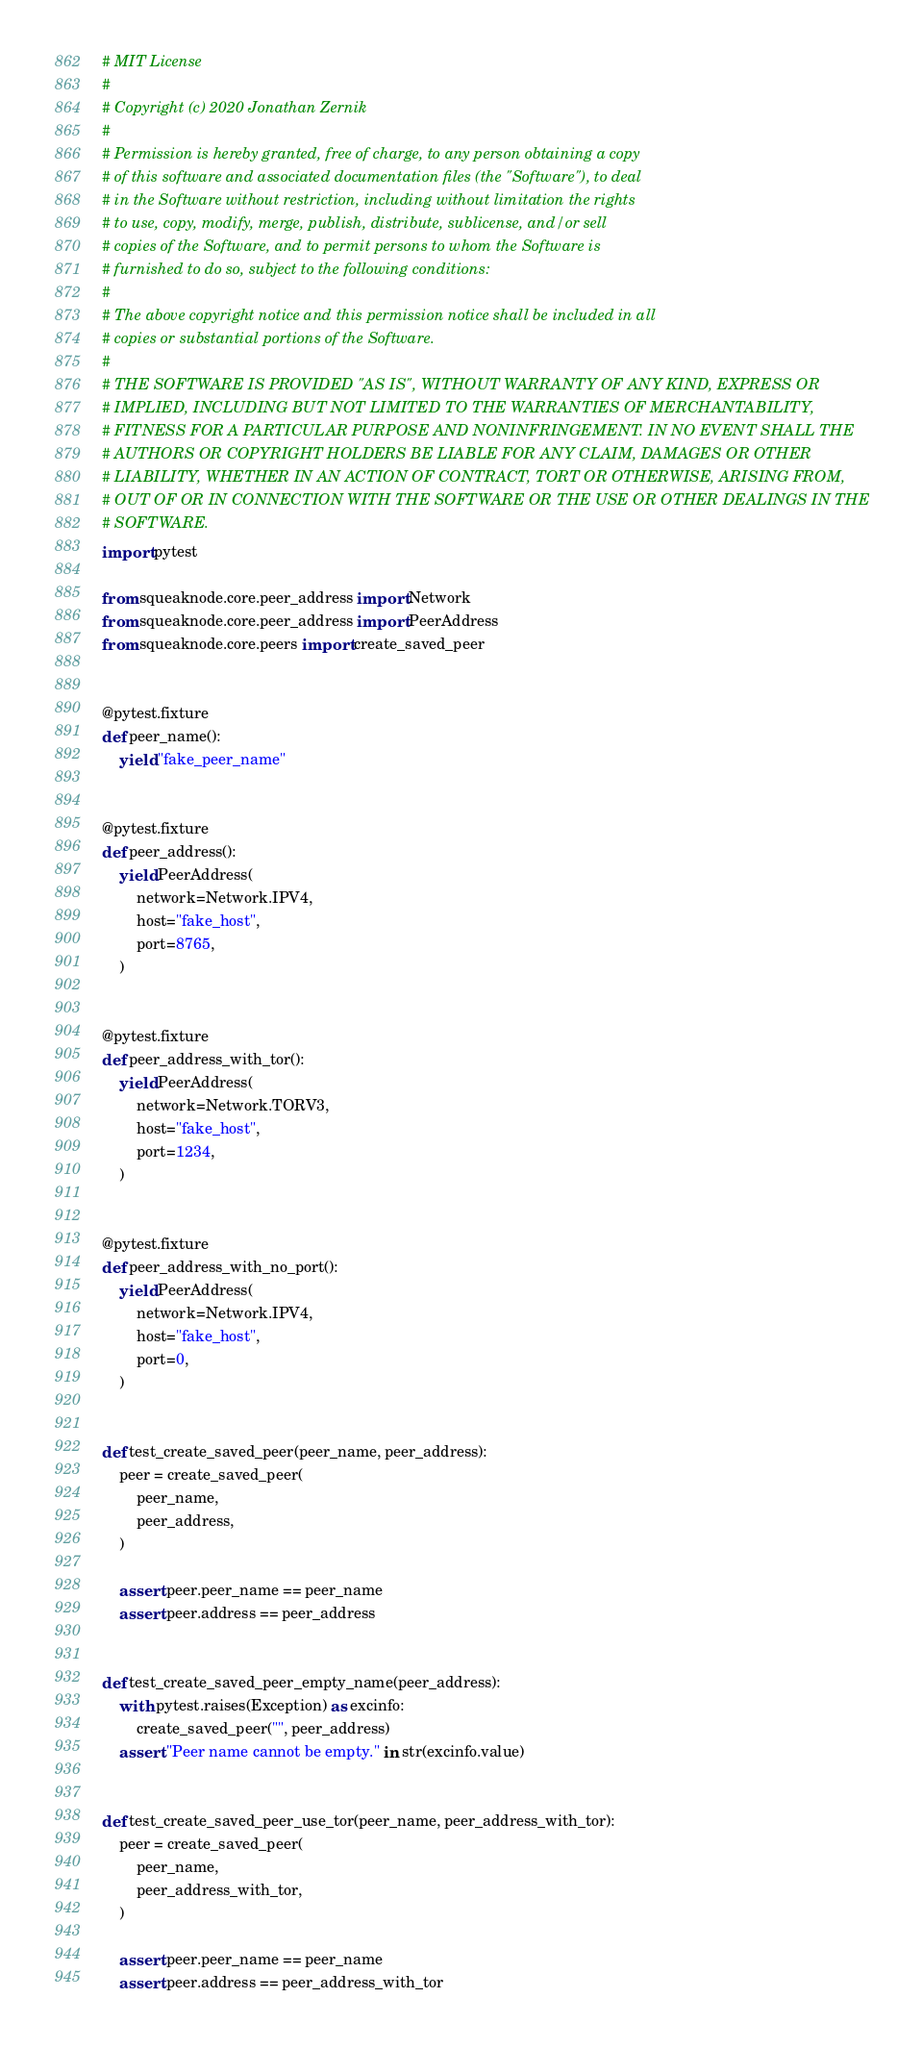<code> <loc_0><loc_0><loc_500><loc_500><_Python_># MIT License
#
# Copyright (c) 2020 Jonathan Zernik
#
# Permission is hereby granted, free of charge, to any person obtaining a copy
# of this software and associated documentation files (the "Software"), to deal
# in the Software without restriction, including without limitation the rights
# to use, copy, modify, merge, publish, distribute, sublicense, and/or sell
# copies of the Software, and to permit persons to whom the Software is
# furnished to do so, subject to the following conditions:
#
# The above copyright notice and this permission notice shall be included in all
# copies or substantial portions of the Software.
#
# THE SOFTWARE IS PROVIDED "AS IS", WITHOUT WARRANTY OF ANY KIND, EXPRESS OR
# IMPLIED, INCLUDING BUT NOT LIMITED TO THE WARRANTIES OF MERCHANTABILITY,
# FITNESS FOR A PARTICULAR PURPOSE AND NONINFRINGEMENT. IN NO EVENT SHALL THE
# AUTHORS OR COPYRIGHT HOLDERS BE LIABLE FOR ANY CLAIM, DAMAGES OR OTHER
# LIABILITY, WHETHER IN AN ACTION OF CONTRACT, TORT OR OTHERWISE, ARISING FROM,
# OUT OF OR IN CONNECTION WITH THE SOFTWARE OR THE USE OR OTHER DEALINGS IN THE
# SOFTWARE.
import pytest

from squeaknode.core.peer_address import Network
from squeaknode.core.peer_address import PeerAddress
from squeaknode.core.peers import create_saved_peer


@pytest.fixture
def peer_name():
    yield "fake_peer_name"


@pytest.fixture
def peer_address():
    yield PeerAddress(
        network=Network.IPV4,
        host="fake_host",
        port=8765,
    )


@pytest.fixture
def peer_address_with_tor():
    yield PeerAddress(
        network=Network.TORV3,
        host="fake_host",
        port=1234,
    )


@pytest.fixture
def peer_address_with_no_port():
    yield PeerAddress(
        network=Network.IPV4,
        host="fake_host",
        port=0,
    )


def test_create_saved_peer(peer_name, peer_address):
    peer = create_saved_peer(
        peer_name,
        peer_address,
    )

    assert peer.peer_name == peer_name
    assert peer.address == peer_address


def test_create_saved_peer_empty_name(peer_address):
    with pytest.raises(Exception) as excinfo:
        create_saved_peer("", peer_address)
    assert "Peer name cannot be empty." in str(excinfo.value)


def test_create_saved_peer_use_tor(peer_name, peer_address_with_tor):
    peer = create_saved_peer(
        peer_name,
        peer_address_with_tor,
    )

    assert peer.peer_name == peer_name
    assert peer.address == peer_address_with_tor
</code> 